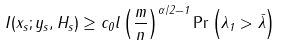Convert formula to latex. <formula><loc_0><loc_0><loc_500><loc_500>I ( { x } _ { s } ; { y } _ { s } , { H } _ { s } ) \geq c _ { 0 } l \left ( \frac { m } { n } \right ) ^ { \alpha / 2 - 1 } \Pr \left ( \lambda _ { 1 } > \bar { \lambda } \right )</formula> 